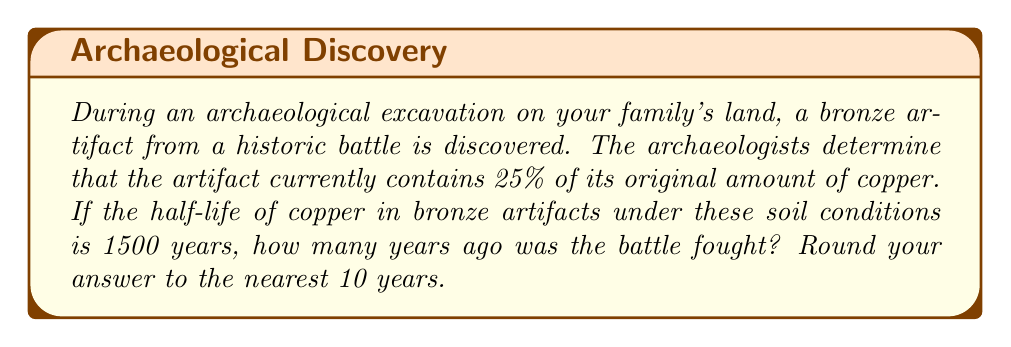Can you answer this question? Let's approach this problem step-by-step using logarithmic equations:

1) Let $t$ be the time in years since the battle.

2) The decay of copper in the artifact follows an exponential decay model:
   $A(t) = A_0 \cdot (0.5)^{t/1500}$
   where $A(t)$ is the amount remaining after time $t$, and $A_0$ is the initial amount.

3) We know that 25% of the original copper remains, so:
   $0.25 = (0.5)^{t/1500}$

4) Taking the natural logarithm of both sides:
   $\ln(0.25) = \ln((0.5)^{t/1500})$

5) Using the logarithm property $\ln(x^n) = n\ln(x)$:
   $\ln(0.25) = \frac{t}{1500} \ln(0.5)$

6) Solving for $t$:
   $t = 1500 \cdot \frac{\ln(0.25)}{\ln(0.5)}$

7) Calculate:
   $t = 1500 \cdot \frac{\ln(0.25)}{\ln(0.5)} \approx 3000$

8) Rounding to the nearest 10 years:
   $t \approx 3000$ years
Answer: 3000 years 